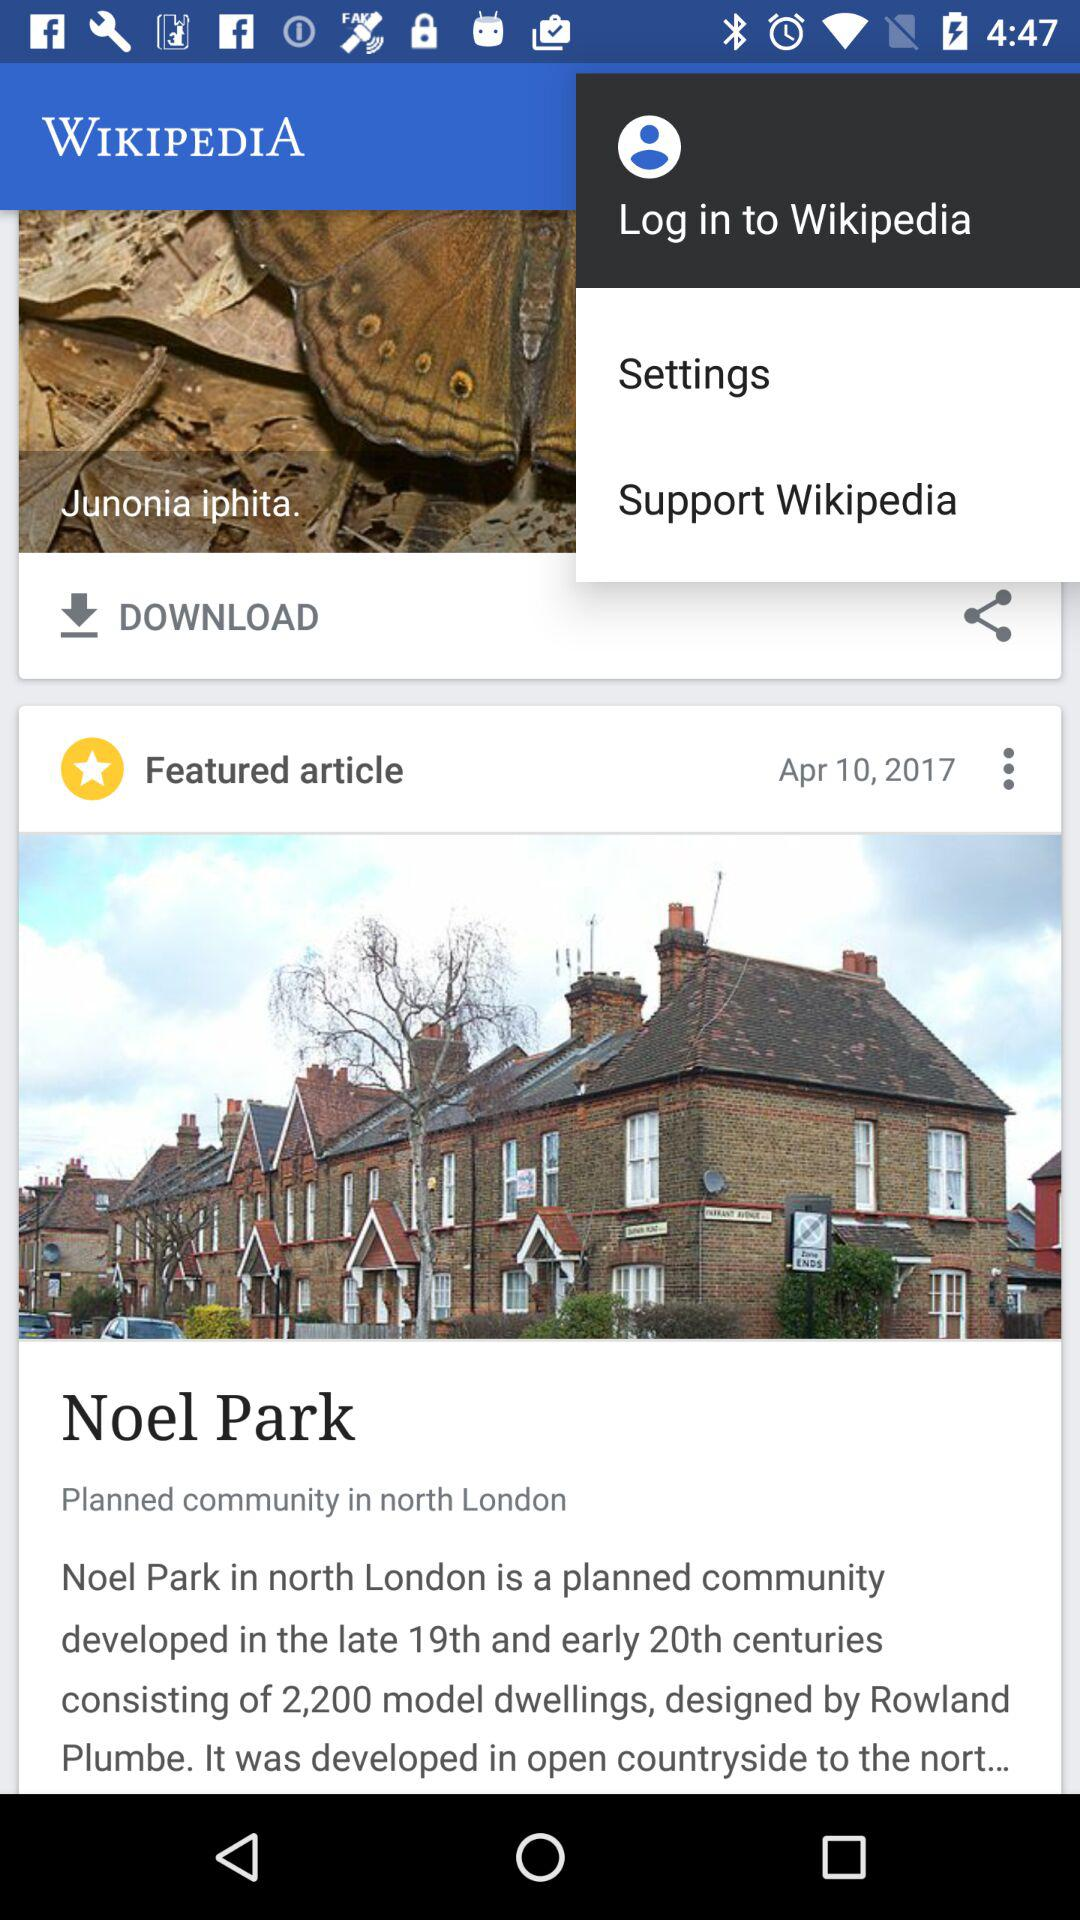To what application can we log in? You can log in to the application "Wikipedia". 